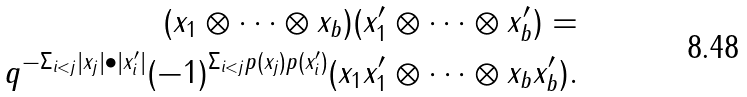<formula> <loc_0><loc_0><loc_500><loc_500>( x _ { 1 } \otimes \cdots \otimes x _ { b } ) ( x _ { 1 } ^ { \prime } \otimes \cdots \otimes x _ { b } ^ { \prime } ) = \\ q ^ { - \Sigma _ { i < j } | x _ { j } | \bullet | x _ { i } ^ { \prime } | } ( - 1 ) ^ { \Sigma _ { i < j } p ( x _ { j } ) p ( x _ { i } ^ { \prime } ) } ( x _ { 1 } x _ { 1 } ^ { \prime } \otimes \cdots \otimes x _ { b } x _ { b } ^ { \prime } ) .</formula> 